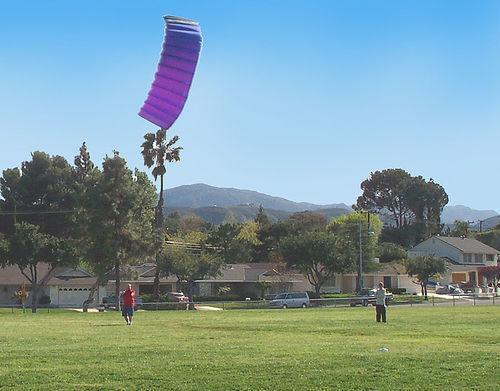What does the man in red hold in his hands?
Choose the right answer from the provided options to respond to the question.
Options: Bait, kite strings, food, nothing. Kite strings. 